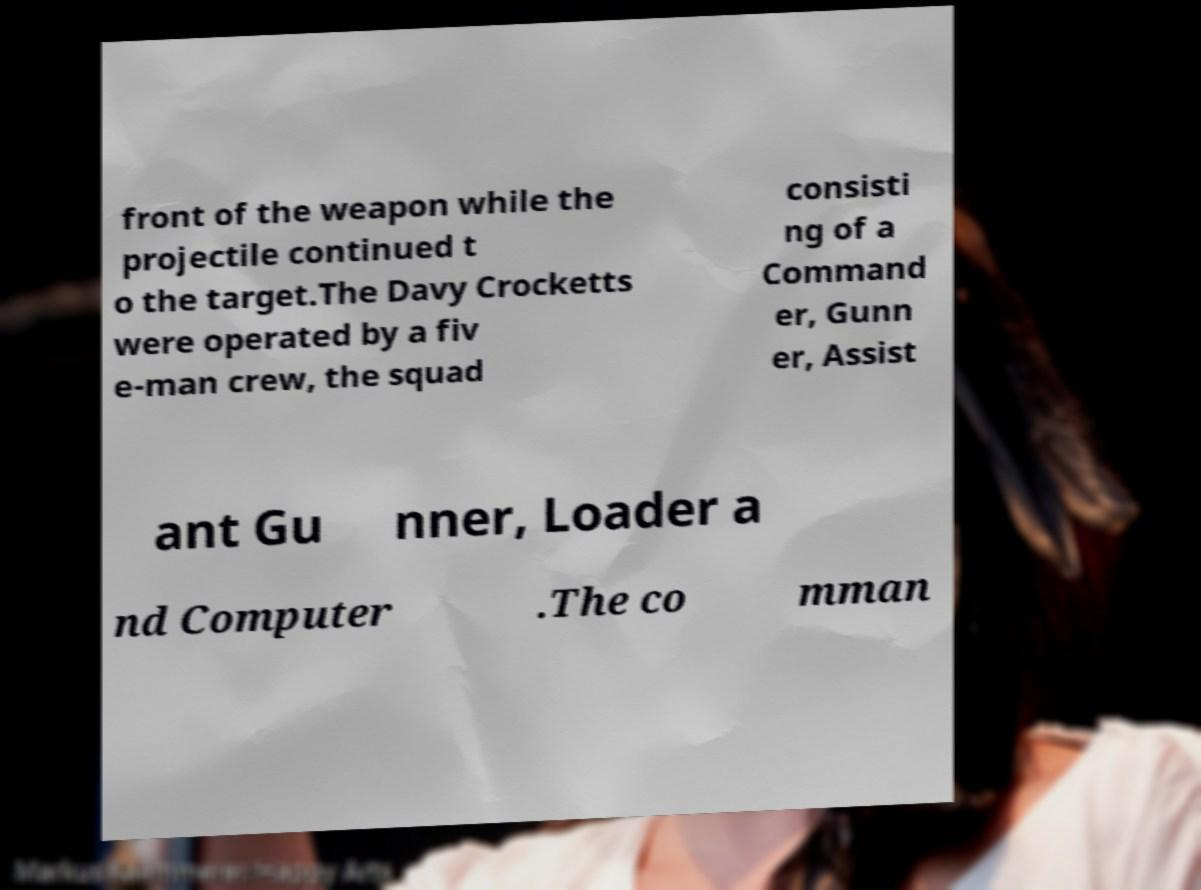Can you accurately transcribe the text from the provided image for me? front of the weapon while the projectile continued t o the target.The Davy Crocketts were operated by a fiv e-man crew, the squad consisti ng of a Command er, Gunn er, Assist ant Gu nner, Loader a nd Computer .The co mman 